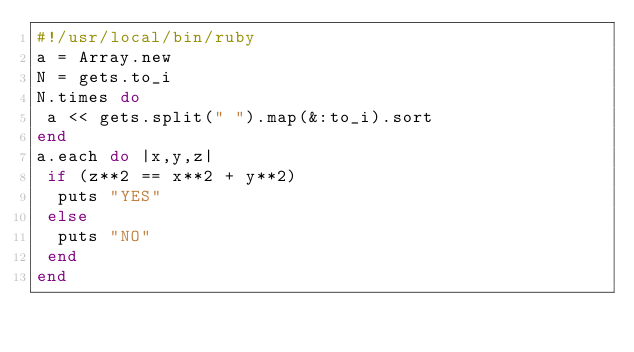Convert code to text. <code><loc_0><loc_0><loc_500><loc_500><_Ruby_>#!/usr/local/bin/ruby
a = Array.new
N = gets.to_i
N.times do
 a << gets.split(" ").map(&:to_i).sort
end
a.each do |x,y,z|
 if (z**2 == x**2 + y**2)
  puts "YES"
 else
  puts "NO"
 end
end</code> 